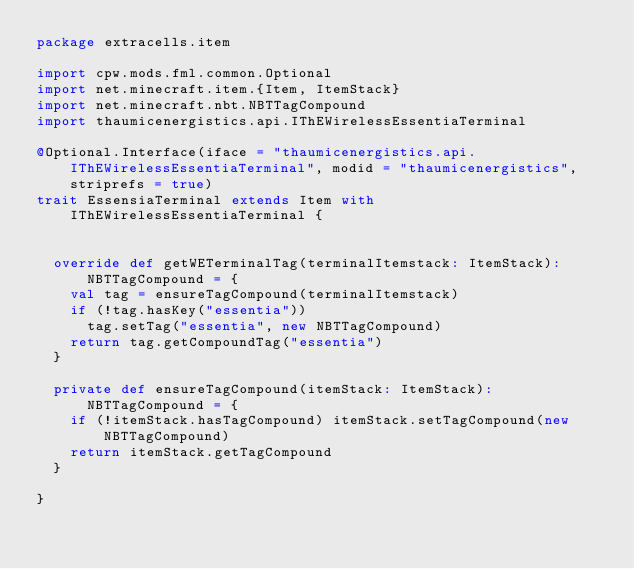Convert code to text. <code><loc_0><loc_0><loc_500><loc_500><_Scala_>package extracells.item

import cpw.mods.fml.common.Optional
import net.minecraft.item.{Item, ItemStack}
import net.minecraft.nbt.NBTTagCompound
import thaumicenergistics.api.IThEWirelessEssentiaTerminal

@Optional.Interface(iface = "thaumicenergistics.api.IThEWirelessEssentiaTerminal", modid = "thaumicenergistics", striprefs = true)
trait EssensiaTerminal extends Item with IThEWirelessEssentiaTerminal {


  override def getWETerminalTag(terminalItemstack: ItemStack): NBTTagCompound = {
    val tag = ensureTagCompound(terminalItemstack)
    if (!tag.hasKey("essentia"))
      tag.setTag("essentia", new NBTTagCompound)
    return tag.getCompoundTag("essentia")
  }

  private def ensureTagCompound(itemStack: ItemStack): NBTTagCompound = {
    if (!itemStack.hasTagCompound) itemStack.setTagCompound(new NBTTagCompound)
    return itemStack.getTagCompound
  }

}
</code> 